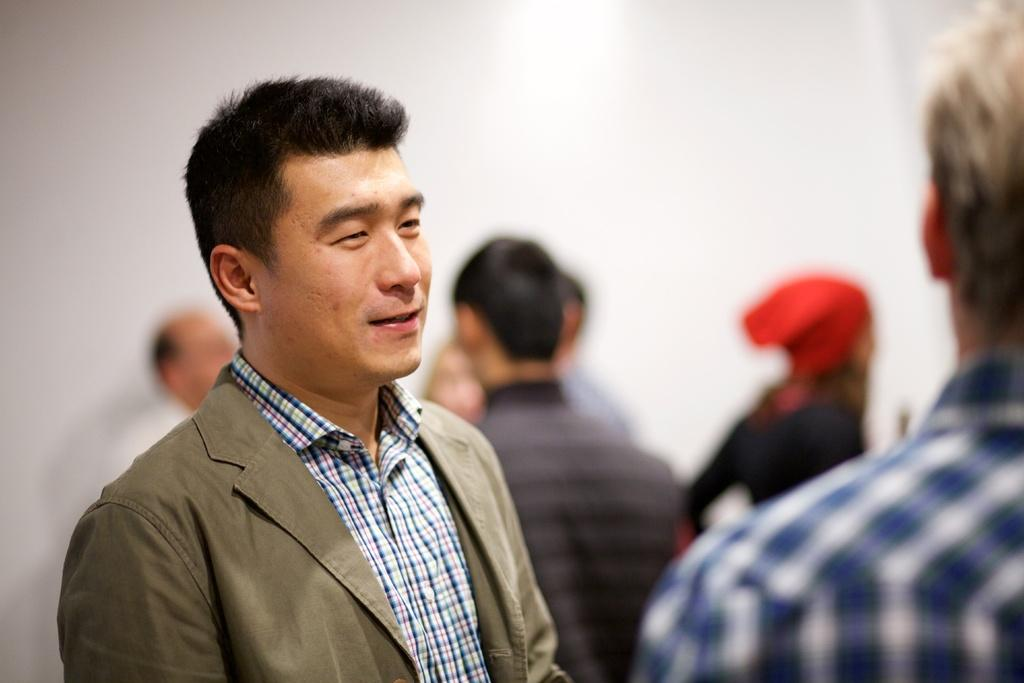What is the person in the image doing? The person in the image is standing and smiling. What can be seen in the background of the image? There is a group of people and a wall visible in the background of the image. What type of crate is being used by the person to whistle in the image? There is no crate or whistling activity present in the image. 